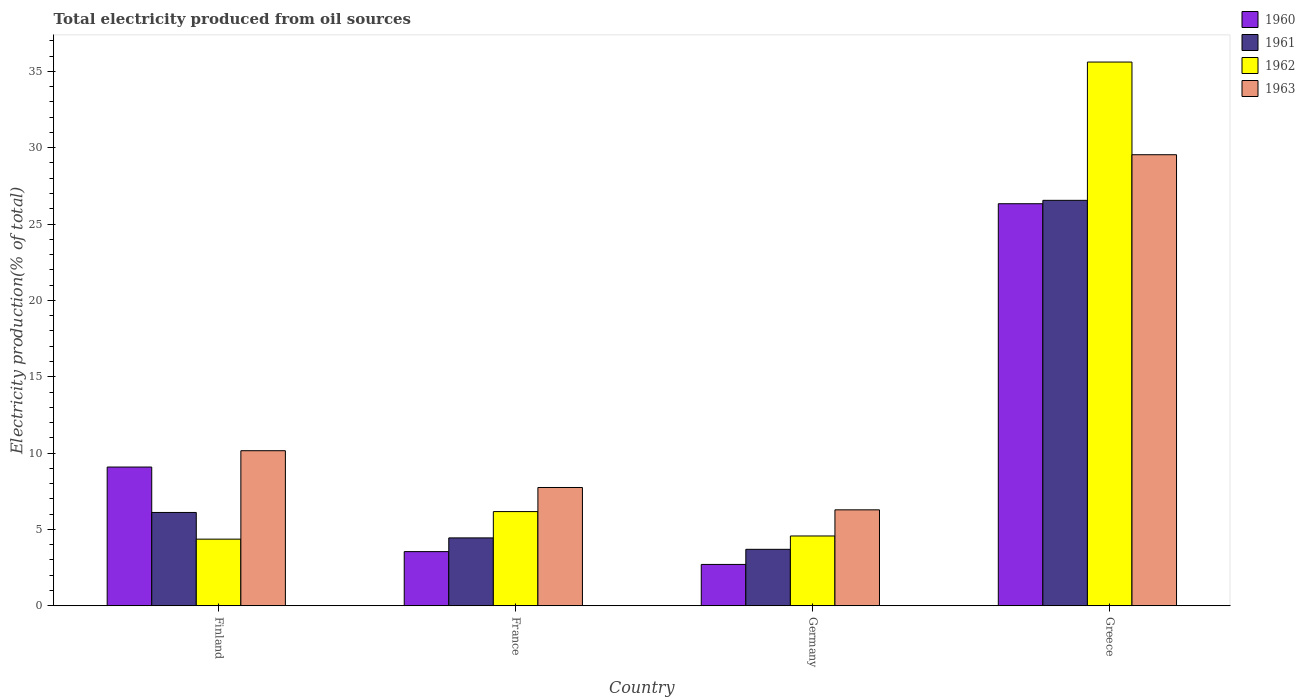Are the number of bars on each tick of the X-axis equal?
Give a very brief answer. Yes. How many bars are there on the 4th tick from the left?
Ensure brevity in your answer.  4. How many bars are there on the 1st tick from the right?
Your response must be concise. 4. In how many cases, is the number of bars for a given country not equal to the number of legend labels?
Your answer should be very brief. 0. What is the total electricity produced in 1962 in France?
Your answer should be very brief. 6.17. Across all countries, what is the maximum total electricity produced in 1963?
Give a very brief answer. 29.54. Across all countries, what is the minimum total electricity produced in 1961?
Give a very brief answer. 3.7. In which country was the total electricity produced in 1960 maximum?
Provide a short and direct response. Greece. What is the total total electricity produced in 1963 in the graph?
Keep it short and to the point. 53.73. What is the difference between the total electricity produced in 1962 in France and that in Germany?
Provide a succinct answer. 1.6. What is the difference between the total electricity produced in 1963 in France and the total electricity produced in 1962 in Germany?
Offer a terse response. 3.17. What is the average total electricity produced in 1962 per country?
Your answer should be compact. 12.68. What is the difference between the total electricity produced of/in 1961 and total electricity produced of/in 1962 in France?
Provide a short and direct response. -1.72. What is the ratio of the total electricity produced in 1962 in Germany to that in Greece?
Keep it short and to the point. 0.13. Is the total electricity produced in 1962 in France less than that in Greece?
Your answer should be compact. Yes. What is the difference between the highest and the second highest total electricity produced in 1961?
Your response must be concise. 22.11. What is the difference between the highest and the lowest total electricity produced in 1961?
Give a very brief answer. 22.86. Is the sum of the total electricity produced in 1963 in Finland and Germany greater than the maximum total electricity produced in 1960 across all countries?
Your answer should be compact. No. Is it the case that in every country, the sum of the total electricity produced in 1960 and total electricity produced in 1963 is greater than the sum of total electricity produced in 1962 and total electricity produced in 1961?
Provide a short and direct response. Yes. How many bars are there?
Your answer should be compact. 16. Are all the bars in the graph horizontal?
Ensure brevity in your answer.  No. What is the difference between two consecutive major ticks on the Y-axis?
Offer a terse response. 5. Are the values on the major ticks of Y-axis written in scientific E-notation?
Your answer should be very brief. No. Does the graph contain any zero values?
Make the answer very short. No. Does the graph contain grids?
Provide a short and direct response. No. How many legend labels are there?
Offer a terse response. 4. What is the title of the graph?
Your response must be concise. Total electricity produced from oil sources. What is the label or title of the X-axis?
Keep it short and to the point. Country. What is the Electricity production(% of total) in 1960 in Finland?
Your response must be concise. 9.09. What is the Electricity production(% of total) in 1961 in Finland?
Offer a very short reply. 6.11. What is the Electricity production(% of total) of 1962 in Finland?
Keep it short and to the point. 4.36. What is the Electricity production(% of total) in 1963 in Finland?
Your answer should be compact. 10.16. What is the Electricity production(% of total) in 1960 in France?
Keep it short and to the point. 3.55. What is the Electricity production(% of total) in 1961 in France?
Your answer should be compact. 4.45. What is the Electricity production(% of total) in 1962 in France?
Provide a succinct answer. 6.17. What is the Electricity production(% of total) of 1963 in France?
Give a very brief answer. 7.75. What is the Electricity production(% of total) in 1960 in Germany?
Make the answer very short. 2.71. What is the Electricity production(% of total) in 1961 in Germany?
Your response must be concise. 3.7. What is the Electricity production(% of total) of 1962 in Germany?
Offer a very short reply. 4.57. What is the Electricity production(% of total) in 1963 in Germany?
Make the answer very short. 6.28. What is the Electricity production(% of total) in 1960 in Greece?
Keep it short and to the point. 26.33. What is the Electricity production(% of total) in 1961 in Greece?
Ensure brevity in your answer.  26.55. What is the Electricity production(% of total) of 1962 in Greece?
Ensure brevity in your answer.  35.61. What is the Electricity production(% of total) of 1963 in Greece?
Your answer should be compact. 29.54. Across all countries, what is the maximum Electricity production(% of total) in 1960?
Your response must be concise. 26.33. Across all countries, what is the maximum Electricity production(% of total) in 1961?
Your answer should be compact. 26.55. Across all countries, what is the maximum Electricity production(% of total) of 1962?
Ensure brevity in your answer.  35.61. Across all countries, what is the maximum Electricity production(% of total) in 1963?
Keep it short and to the point. 29.54. Across all countries, what is the minimum Electricity production(% of total) in 1960?
Give a very brief answer. 2.71. Across all countries, what is the minimum Electricity production(% of total) of 1961?
Your answer should be very brief. 3.7. Across all countries, what is the minimum Electricity production(% of total) of 1962?
Keep it short and to the point. 4.36. Across all countries, what is the minimum Electricity production(% of total) of 1963?
Ensure brevity in your answer.  6.28. What is the total Electricity production(% of total) of 1960 in the graph?
Ensure brevity in your answer.  41.68. What is the total Electricity production(% of total) in 1961 in the graph?
Make the answer very short. 40.81. What is the total Electricity production(% of total) in 1962 in the graph?
Offer a terse response. 50.72. What is the total Electricity production(% of total) of 1963 in the graph?
Offer a terse response. 53.73. What is the difference between the Electricity production(% of total) of 1960 in Finland and that in France?
Your response must be concise. 5.54. What is the difference between the Electricity production(% of total) of 1961 in Finland and that in France?
Keep it short and to the point. 1.67. What is the difference between the Electricity production(% of total) of 1962 in Finland and that in France?
Your answer should be compact. -1.8. What is the difference between the Electricity production(% of total) in 1963 in Finland and that in France?
Ensure brevity in your answer.  2.41. What is the difference between the Electricity production(% of total) in 1960 in Finland and that in Germany?
Provide a succinct answer. 6.38. What is the difference between the Electricity production(% of total) of 1961 in Finland and that in Germany?
Your response must be concise. 2.41. What is the difference between the Electricity production(% of total) in 1962 in Finland and that in Germany?
Provide a succinct answer. -0.21. What is the difference between the Electricity production(% of total) in 1963 in Finland and that in Germany?
Provide a short and direct response. 3.87. What is the difference between the Electricity production(% of total) in 1960 in Finland and that in Greece?
Offer a terse response. -17.24. What is the difference between the Electricity production(% of total) in 1961 in Finland and that in Greece?
Offer a very short reply. -20.44. What is the difference between the Electricity production(% of total) of 1962 in Finland and that in Greece?
Provide a short and direct response. -31.25. What is the difference between the Electricity production(% of total) of 1963 in Finland and that in Greece?
Give a very brief answer. -19.38. What is the difference between the Electricity production(% of total) of 1960 in France and that in Germany?
Make the answer very short. 0.84. What is the difference between the Electricity production(% of total) in 1961 in France and that in Germany?
Your answer should be compact. 0.75. What is the difference between the Electricity production(% of total) of 1962 in France and that in Germany?
Provide a succinct answer. 1.6. What is the difference between the Electricity production(% of total) of 1963 in France and that in Germany?
Provide a short and direct response. 1.46. What is the difference between the Electricity production(% of total) in 1960 in France and that in Greece?
Give a very brief answer. -22.78. What is the difference between the Electricity production(% of total) of 1961 in France and that in Greece?
Provide a succinct answer. -22.11. What is the difference between the Electricity production(% of total) of 1962 in France and that in Greece?
Make the answer very short. -29.44. What is the difference between the Electricity production(% of total) in 1963 in France and that in Greece?
Keep it short and to the point. -21.79. What is the difference between the Electricity production(% of total) in 1960 in Germany and that in Greece?
Make the answer very short. -23.62. What is the difference between the Electricity production(% of total) in 1961 in Germany and that in Greece?
Your answer should be very brief. -22.86. What is the difference between the Electricity production(% of total) in 1962 in Germany and that in Greece?
Your response must be concise. -31.04. What is the difference between the Electricity production(% of total) of 1963 in Germany and that in Greece?
Make the answer very short. -23.26. What is the difference between the Electricity production(% of total) of 1960 in Finland and the Electricity production(% of total) of 1961 in France?
Your answer should be very brief. 4.64. What is the difference between the Electricity production(% of total) in 1960 in Finland and the Electricity production(% of total) in 1962 in France?
Offer a terse response. 2.92. What is the difference between the Electricity production(% of total) in 1960 in Finland and the Electricity production(% of total) in 1963 in France?
Provide a succinct answer. 1.34. What is the difference between the Electricity production(% of total) of 1961 in Finland and the Electricity production(% of total) of 1962 in France?
Offer a terse response. -0.06. What is the difference between the Electricity production(% of total) of 1961 in Finland and the Electricity production(% of total) of 1963 in France?
Make the answer very short. -1.64. What is the difference between the Electricity production(% of total) of 1962 in Finland and the Electricity production(% of total) of 1963 in France?
Ensure brevity in your answer.  -3.38. What is the difference between the Electricity production(% of total) of 1960 in Finland and the Electricity production(% of total) of 1961 in Germany?
Offer a terse response. 5.39. What is the difference between the Electricity production(% of total) in 1960 in Finland and the Electricity production(% of total) in 1962 in Germany?
Keep it short and to the point. 4.51. What is the difference between the Electricity production(% of total) in 1960 in Finland and the Electricity production(% of total) in 1963 in Germany?
Your response must be concise. 2.8. What is the difference between the Electricity production(% of total) in 1961 in Finland and the Electricity production(% of total) in 1962 in Germany?
Give a very brief answer. 1.54. What is the difference between the Electricity production(% of total) in 1961 in Finland and the Electricity production(% of total) in 1963 in Germany?
Offer a very short reply. -0.17. What is the difference between the Electricity production(% of total) of 1962 in Finland and the Electricity production(% of total) of 1963 in Germany?
Your response must be concise. -1.92. What is the difference between the Electricity production(% of total) of 1960 in Finland and the Electricity production(% of total) of 1961 in Greece?
Offer a terse response. -17.47. What is the difference between the Electricity production(% of total) of 1960 in Finland and the Electricity production(% of total) of 1962 in Greece?
Your answer should be very brief. -26.52. What is the difference between the Electricity production(% of total) of 1960 in Finland and the Electricity production(% of total) of 1963 in Greece?
Give a very brief answer. -20.45. What is the difference between the Electricity production(% of total) in 1961 in Finland and the Electricity production(% of total) in 1962 in Greece?
Your response must be concise. -29.5. What is the difference between the Electricity production(% of total) of 1961 in Finland and the Electricity production(% of total) of 1963 in Greece?
Provide a short and direct response. -23.43. What is the difference between the Electricity production(% of total) of 1962 in Finland and the Electricity production(% of total) of 1963 in Greece?
Ensure brevity in your answer.  -25.18. What is the difference between the Electricity production(% of total) of 1960 in France and the Electricity production(% of total) of 1961 in Germany?
Make the answer very short. -0.15. What is the difference between the Electricity production(% of total) in 1960 in France and the Electricity production(% of total) in 1962 in Germany?
Offer a terse response. -1.02. What is the difference between the Electricity production(% of total) in 1960 in France and the Electricity production(% of total) in 1963 in Germany?
Your answer should be very brief. -2.74. What is the difference between the Electricity production(% of total) in 1961 in France and the Electricity production(% of total) in 1962 in Germany?
Your answer should be very brief. -0.13. What is the difference between the Electricity production(% of total) of 1961 in France and the Electricity production(% of total) of 1963 in Germany?
Your answer should be compact. -1.84. What is the difference between the Electricity production(% of total) in 1962 in France and the Electricity production(% of total) in 1963 in Germany?
Offer a very short reply. -0.11. What is the difference between the Electricity production(% of total) of 1960 in France and the Electricity production(% of total) of 1961 in Greece?
Give a very brief answer. -23.01. What is the difference between the Electricity production(% of total) of 1960 in France and the Electricity production(% of total) of 1962 in Greece?
Give a very brief answer. -32.06. What is the difference between the Electricity production(% of total) in 1960 in France and the Electricity production(% of total) in 1963 in Greece?
Offer a very short reply. -25.99. What is the difference between the Electricity production(% of total) of 1961 in France and the Electricity production(% of total) of 1962 in Greece?
Offer a terse response. -31.16. What is the difference between the Electricity production(% of total) of 1961 in France and the Electricity production(% of total) of 1963 in Greece?
Provide a succinct answer. -25.09. What is the difference between the Electricity production(% of total) of 1962 in France and the Electricity production(% of total) of 1963 in Greece?
Provide a succinct answer. -23.37. What is the difference between the Electricity production(% of total) in 1960 in Germany and the Electricity production(% of total) in 1961 in Greece?
Offer a very short reply. -23.85. What is the difference between the Electricity production(% of total) of 1960 in Germany and the Electricity production(% of total) of 1962 in Greece?
Offer a terse response. -32.9. What is the difference between the Electricity production(% of total) of 1960 in Germany and the Electricity production(% of total) of 1963 in Greece?
Provide a short and direct response. -26.83. What is the difference between the Electricity production(% of total) in 1961 in Germany and the Electricity production(% of total) in 1962 in Greece?
Offer a very short reply. -31.91. What is the difference between the Electricity production(% of total) in 1961 in Germany and the Electricity production(% of total) in 1963 in Greece?
Offer a terse response. -25.84. What is the difference between the Electricity production(% of total) of 1962 in Germany and the Electricity production(% of total) of 1963 in Greece?
Offer a terse response. -24.97. What is the average Electricity production(% of total) of 1960 per country?
Give a very brief answer. 10.42. What is the average Electricity production(% of total) in 1961 per country?
Provide a succinct answer. 10.2. What is the average Electricity production(% of total) in 1962 per country?
Your answer should be very brief. 12.68. What is the average Electricity production(% of total) in 1963 per country?
Your answer should be very brief. 13.43. What is the difference between the Electricity production(% of total) in 1960 and Electricity production(% of total) in 1961 in Finland?
Ensure brevity in your answer.  2.98. What is the difference between the Electricity production(% of total) of 1960 and Electricity production(% of total) of 1962 in Finland?
Your answer should be compact. 4.72. What is the difference between the Electricity production(% of total) of 1960 and Electricity production(% of total) of 1963 in Finland?
Your answer should be compact. -1.07. What is the difference between the Electricity production(% of total) in 1961 and Electricity production(% of total) in 1962 in Finland?
Your answer should be very brief. 1.75. What is the difference between the Electricity production(% of total) in 1961 and Electricity production(% of total) in 1963 in Finland?
Provide a succinct answer. -4.04. What is the difference between the Electricity production(% of total) of 1962 and Electricity production(% of total) of 1963 in Finland?
Ensure brevity in your answer.  -5.79. What is the difference between the Electricity production(% of total) in 1960 and Electricity production(% of total) in 1961 in France?
Make the answer very short. -0.9. What is the difference between the Electricity production(% of total) in 1960 and Electricity production(% of total) in 1962 in France?
Provide a short and direct response. -2.62. What is the difference between the Electricity production(% of total) in 1960 and Electricity production(% of total) in 1963 in France?
Keep it short and to the point. -4.2. What is the difference between the Electricity production(% of total) in 1961 and Electricity production(% of total) in 1962 in France?
Your response must be concise. -1.72. What is the difference between the Electricity production(% of total) in 1961 and Electricity production(% of total) in 1963 in France?
Offer a terse response. -3.3. What is the difference between the Electricity production(% of total) of 1962 and Electricity production(% of total) of 1963 in France?
Make the answer very short. -1.58. What is the difference between the Electricity production(% of total) of 1960 and Electricity production(% of total) of 1961 in Germany?
Your answer should be very brief. -0.99. What is the difference between the Electricity production(% of total) in 1960 and Electricity production(% of total) in 1962 in Germany?
Keep it short and to the point. -1.86. What is the difference between the Electricity production(% of total) of 1960 and Electricity production(% of total) of 1963 in Germany?
Ensure brevity in your answer.  -3.58. What is the difference between the Electricity production(% of total) in 1961 and Electricity production(% of total) in 1962 in Germany?
Ensure brevity in your answer.  -0.87. What is the difference between the Electricity production(% of total) in 1961 and Electricity production(% of total) in 1963 in Germany?
Provide a short and direct response. -2.59. What is the difference between the Electricity production(% of total) of 1962 and Electricity production(% of total) of 1963 in Germany?
Keep it short and to the point. -1.71. What is the difference between the Electricity production(% of total) of 1960 and Electricity production(% of total) of 1961 in Greece?
Your answer should be very brief. -0.22. What is the difference between the Electricity production(% of total) of 1960 and Electricity production(% of total) of 1962 in Greece?
Offer a terse response. -9.28. What is the difference between the Electricity production(% of total) in 1960 and Electricity production(% of total) in 1963 in Greece?
Offer a very short reply. -3.21. What is the difference between the Electricity production(% of total) of 1961 and Electricity production(% of total) of 1962 in Greece?
Provide a short and direct response. -9.06. What is the difference between the Electricity production(% of total) in 1961 and Electricity production(% of total) in 1963 in Greece?
Make the answer very short. -2.99. What is the difference between the Electricity production(% of total) in 1962 and Electricity production(% of total) in 1963 in Greece?
Offer a terse response. 6.07. What is the ratio of the Electricity production(% of total) in 1960 in Finland to that in France?
Provide a short and direct response. 2.56. What is the ratio of the Electricity production(% of total) in 1961 in Finland to that in France?
Your answer should be very brief. 1.37. What is the ratio of the Electricity production(% of total) in 1962 in Finland to that in France?
Make the answer very short. 0.71. What is the ratio of the Electricity production(% of total) of 1963 in Finland to that in France?
Your answer should be very brief. 1.31. What is the ratio of the Electricity production(% of total) of 1960 in Finland to that in Germany?
Offer a terse response. 3.36. What is the ratio of the Electricity production(% of total) of 1961 in Finland to that in Germany?
Give a very brief answer. 1.65. What is the ratio of the Electricity production(% of total) of 1962 in Finland to that in Germany?
Your response must be concise. 0.95. What is the ratio of the Electricity production(% of total) in 1963 in Finland to that in Germany?
Provide a succinct answer. 1.62. What is the ratio of the Electricity production(% of total) of 1960 in Finland to that in Greece?
Provide a succinct answer. 0.35. What is the ratio of the Electricity production(% of total) in 1961 in Finland to that in Greece?
Provide a short and direct response. 0.23. What is the ratio of the Electricity production(% of total) of 1962 in Finland to that in Greece?
Make the answer very short. 0.12. What is the ratio of the Electricity production(% of total) in 1963 in Finland to that in Greece?
Give a very brief answer. 0.34. What is the ratio of the Electricity production(% of total) of 1960 in France to that in Germany?
Provide a short and direct response. 1.31. What is the ratio of the Electricity production(% of total) of 1961 in France to that in Germany?
Provide a succinct answer. 1.2. What is the ratio of the Electricity production(% of total) of 1962 in France to that in Germany?
Ensure brevity in your answer.  1.35. What is the ratio of the Electricity production(% of total) of 1963 in France to that in Germany?
Offer a very short reply. 1.23. What is the ratio of the Electricity production(% of total) in 1960 in France to that in Greece?
Make the answer very short. 0.13. What is the ratio of the Electricity production(% of total) in 1961 in France to that in Greece?
Your answer should be compact. 0.17. What is the ratio of the Electricity production(% of total) of 1962 in France to that in Greece?
Your response must be concise. 0.17. What is the ratio of the Electricity production(% of total) of 1963 in France to that in Greece?
Your answer should be very brief. 0.26. What is the ratio of the Electricity production(% of total) of 1960 in Germany to that in Greece?
Your response must be concise. 0.1. What is the ratio of the Electricity production(% of total) of 1961 in Germany to that in Greece?
Keep it short and to the point. 0.14. What is the ratio of the Electricity production(% of total) in 1962 in Germany to that in Greece?
Your answer should be very brief. 0.13. What is the ratio of the Electricity production(% of total) in 1963 in Germany to that in Greece?
Provide a short and direct response. 0.21. What is the difference between the highest and the second highest Electricity production(% of total) of 1960?
Offer a terse response. 17.24. What is the difference between the highest and the second highest Electricity production(% of total) in 1961?
Give a very brief answer. 20.44. What is the difference between the highest and the second highest Electricity production(% of total) of 1962?
Your response must be concise. 29.44. What is the difference between the highest and the second highest Electricity production(% of total) of 1963?
Keep it short and to the point. 19.38. What is the difference between the highest and the lowest Electricity production(% of total) of 1960?
Keep it short and to the point. 23.62. What is the difference between the highest and the lowest Electricity production(% of total) of 1961?
Ensure brevity in your answer.  22.86. What is the difference between the highest and the lowest Electricity production(% of total) in 1962?
Make the answer very short. 31.25. What is the difference between the highest and the lowest Electricity production(% of total) of 1963?
Provide a succinct answer. 23.26. 